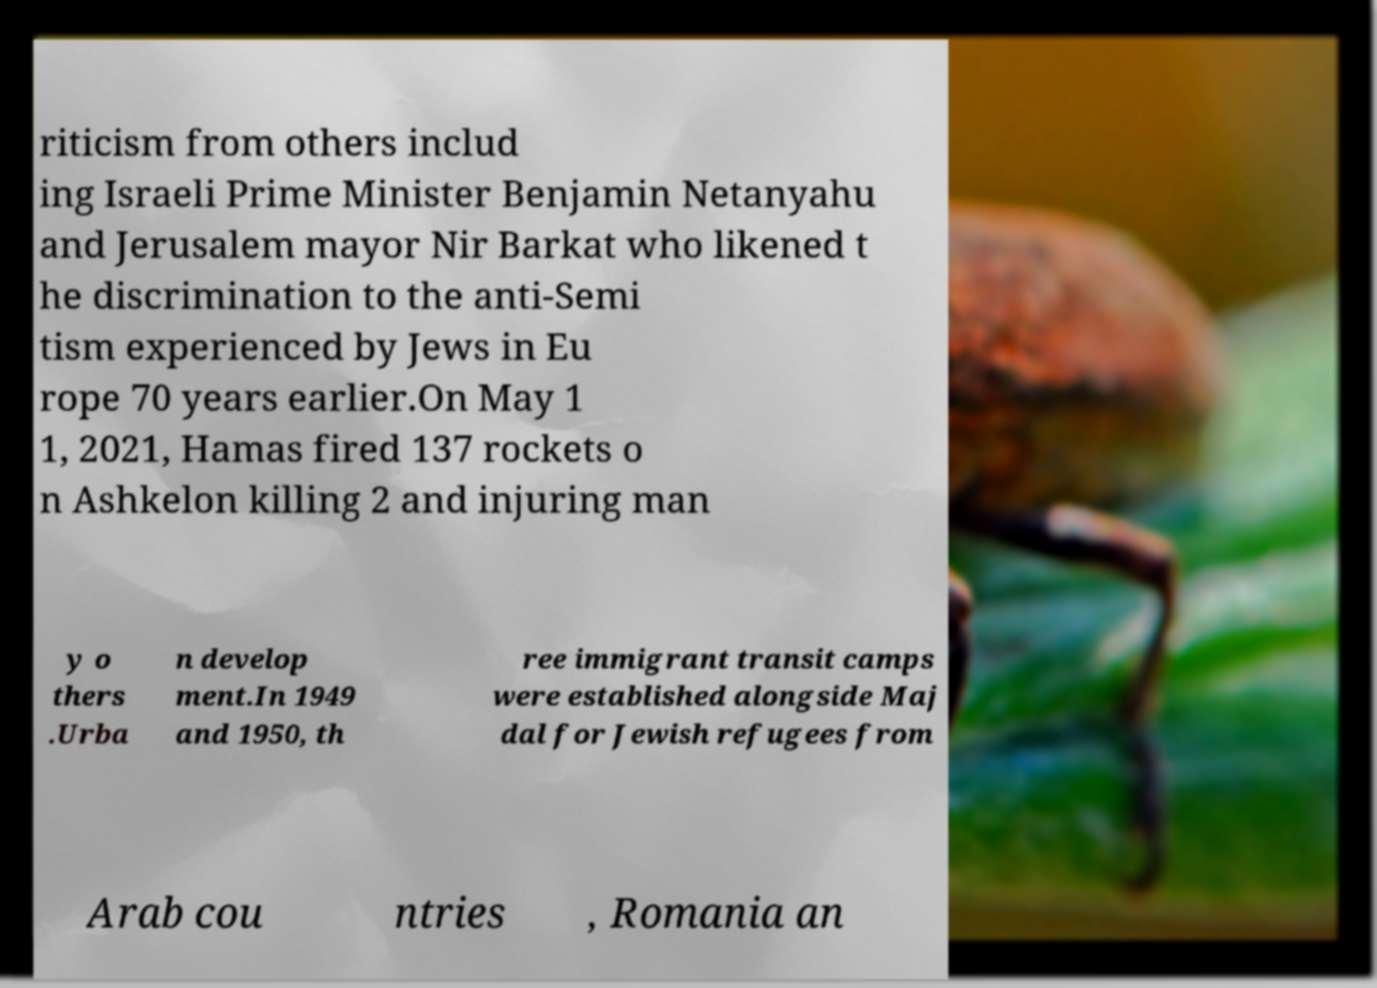I need the written content from this picture converted into text. Can you do that? riticism from others includ ing Israeli Prime Minister Benjamin Netanyahu and Jerusalem mayor Nir Barkat who likened t he discrimination to the anti-Semi tism experienced by Jews in Eu rope 70 years earlier.On May 1 1, 2021, Hamas fired 137 rockets o n Ashkelon killing 2 and injuring man y o thers .Urba n develop ment.In 1949 and 1950, th ree immigrant transit camps were established alongside Maj dal for Jewish refugees from Arab cou ntries , Romania an 